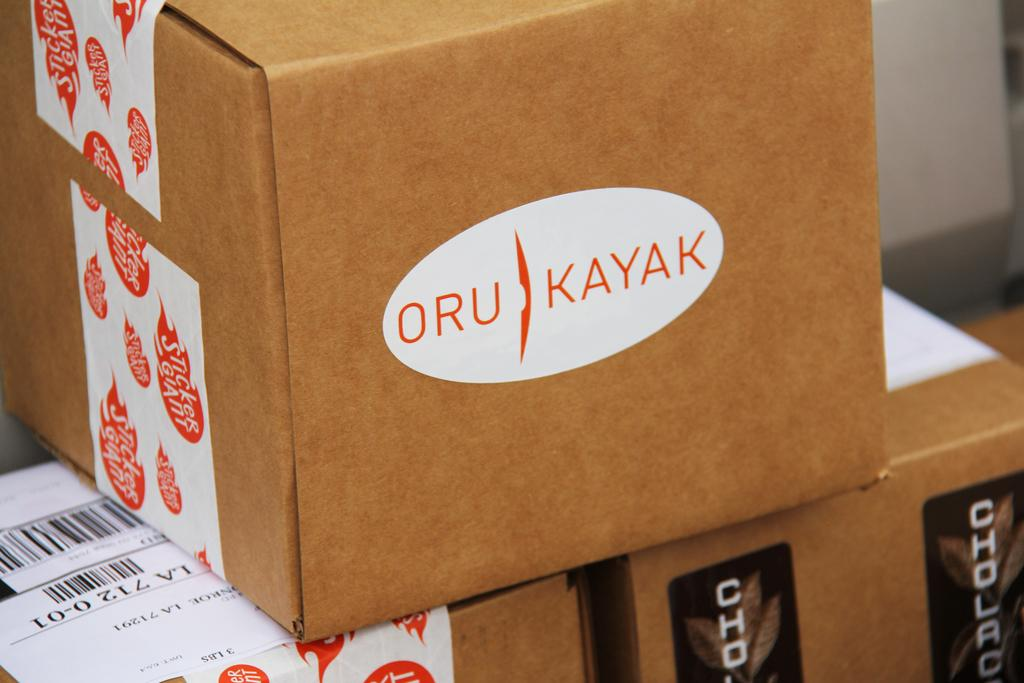<image>
Give a short and clear explanation of the subsequent image. several brown cardboard boxes are stacked and the top one has a white oval with the letters ORU KAYAK on it 